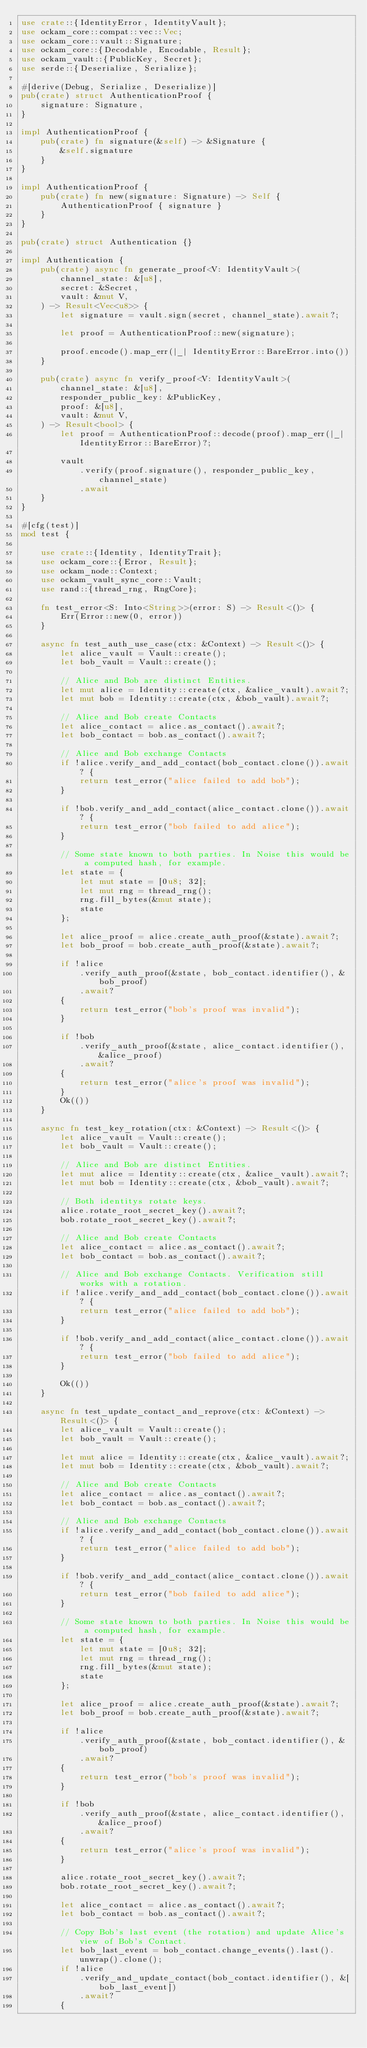Convert code to text. <code><loc_0><loc_0><loc_500><loc_500><_Rust_>use crate::{IdentityError, IdentityVault};
use ockam_core::compat::vec::Vec;
use ockam_core::vault::Signature;
use ockam_core::{Decodable, Encodable, Result};
use ockam_vault::{PublicKey, Secret};
use serde::{Deserialize, Serialize};

#[derive(Debug, Serialize, Deserialize)]
pub(crate) struct AuthenticationProof {
    signature: Signature,
}

impl AuthenticationProof {
    pub(crate) fn signature(&self) -> &Signature {
        &self.signature
    }
}

impl AuthenticationProof {
    pub(crate) fn new(signature: Signature) -> Self {
        AuthenticationProof { signature }
    }
}

pub(crate) struct Authentication {}

impl Authentication {
    pub(crate) async fn generate_proof<V: IdentityVault>(
        channel_state: &[u8],
        secret: &Secret,
        vault: &mut V,
    ) -> Result<Vec<u8>> {
        let signature = vault.sign(secret, channel_state).await?;

        let proof = AuthenticationProof::new(signature);

        proof.encode().map_err(|_| IdentityError::BareError.into())
    }

    pub(crate) async fn verify_proof<V: IdentityVault>(
        channel_state: &[u8],
        responder_public_key: &PublicKey,
        proof: &[u8],
        vault: &mut V,
    ) -> Result<bool> {
        let proof = AuthenticationProof::decode(proof).map_err(|_| IdentityError::BareError)?;

        vault
            .verify(proof.signature(), responder_public_key, channel_state)
            .await
    }
}

#[cfg(test)]
mod test {

    use crate::{Identity, IdentityTrait};
    use ockam_core::{Error, Result};
    use ockam_node::Context;
    use ockam_vault_sync_core::Vault;
    use rand::{thread_rng, RngCore};

    fn test_error<S: Into<String>>(error: S) -> Result<()> {
        Err(Error::new(0, error))
    }

    async fn test_auth_use_case(ctx: &Context) -> Result<()> {
        let alice_vault = Vault::create();
        let bob_vault = Vault::create();

        // Alice and Bob are distinct Entities.
        let mut alice = Identity::create(ctx, &alice_vault).await?;
        let mut bob = Identity::create(ctx, &bob_vault).await?;

        // Alice and Bob create Contacts
        let alice_contact = alice.as_contact().await?;
        let bob_contact = bob.as_contact().await?;

        // Alice and Bob exchange Contacts
        if !alice.verify_and_add_contact(bob_contact.clone()).await? {
            return test_error("alice failed to add bob");
        }

        if !bob.verify_and_add_contact(alice_contact.clone()).await? {
            return test_error("bob failed to add alice");
        }

        // Some state known to both parties. In Noise this would be a computed hash, for example.
        let state = {
            let mut state = [0u8; 32];
            let mut rng = thread_rng();
            rng.fill_bytes(&mut state);
            state
        };

        let alice_proof = alice.create_auth_proof(&state).await?;
        let bob_proof = bob.create_auth_proof(&state).await?;

        if !alice
            .verify_auth_proof(&state, bob_contact.identifier(), &bob_proof)
            .await?
        {
            return test_error("bob's proof was invalid");
        }

        if !bob
            .verify_auth_proof(&state, alice_contact.identifier(), &alice_proof)
            .await?
        {
            return test_error("alice's proof was invalid");
        }
        Ok(())
    }

    async fn test_key_rotation(ctx: &Context) -> Result<()> {
        let alice_vault = Vault::create();
        let bob_vault = Vault::create();

        // Alice and Bob are distinct Entities.
        let mut alice = Identity::create(ctx, &alice_vault).await?;
        let mut bob = Identity::create(ctx, &bob_vault).await?;

        // Both identitys rotate keys.
        alice.rotate_root_secret_key().await?;
        bob.rotate_root_secret_key().await?;

        // Alice and Bob create Contacts
        let alice_contact = alice.as_contact().await?;
        let bob_contact = bob.as_contact().await?;

        // Alice and Bob exchange Contacts. Verification still works with a rotation.
        if !alice.verify_and_add_contact(bob_contact.clone()).await? {
            return test_error("alice failed to add bob");
        }

        if !bob.verify_and_add_contact(alice_contact.clone()).await? {
            return test_error("bob failed to add alice");
        }

        Ok(())
    }

    async fn test_update_contact_and_reprove(ctx: &Context) -> Result<()> {
        let alice_vault = Vault::create();
        let bob_vault = Vault::create();

        let mut alice = Identity::create(ctx, &alice_vault).await?;
        let mut bob = Identity::create(ctx, &bob_vault).await?;

        // Alice and Bob create Contacts
        let alice_contact = alice.as_contact().await?;
        let bob_contact = bob.as_contact().await?;

        // Alice and Bob exchange Contacts
        if !alice.verify_and_add_contact(bob_contact.clone()).await? {
            return test_error("alice failed to add bob");
        }

        if !bob.verify_and_add_contact(alice_contact.clone()).await? {
            return test_error("bob failed to add alice");
        }

        // Some state known to both parties. In Noise this would be a computed hash, for example.
        let state = {
            let mut state = [0u8; 32];
            let mut rng = thread_rng();
            rng.fill_bytes(&mut state);
            state
        };

        let alice_proof = alice.create_auth_proof(&state).await?;
        let bob_proof = bob.create_auth_proof(&state).await?;

        if !alice
            .verify_auth_proof(&state, bob_contact.identifier(), &bob_proof)
            .await?
        {
            return test_error("bob's proof was invalid");
        }

        if !bob
            .verify_auth_proof(&state, alice_contact.identifier(), &alice_proof)
            .await?
        {
            return test_error("alice's proof was invalid");
        }

        alice.rotate_root_secret_key().await?;
        bob.rotate_root_secret_key().await?;

        let alice_contact = alice.as_contact().await?;
        let bob_contact = bob.as_contact().await?;

        // Copy Bob's last event (the rotation) and update Alice's view of Bob's Contact.
        let bob_last_event = bob_contact.change_events().last().unwrap().clone();
        if !alice
            .verify_and_update_contact(bob_contact.identifier(), &[bob_last_event])
            .await?
        {</code> 